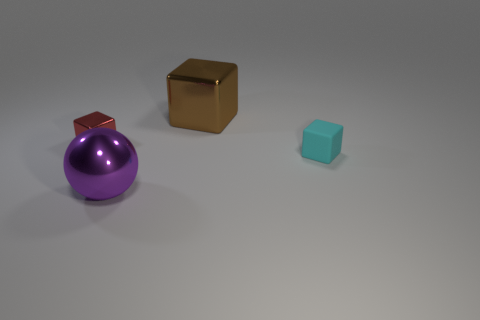Subtract all big cubes. How many cubes are left? 2 Add 3 large blue shiny things. How many objects exist? 7 Subtract all brown blocks. How many blocks are left? 2 Subtract all cubes. How many objects are left? 1 Subtract 2 cubes. How many cubes are left? 1 Subtract all green blocks. How many cyan spheres are left? 0 Subtract all tiny yellow metallic spheres. Subtract all large brown metallic cubes. How many objects are left? 3 Add 1 small shiny cubes. How many small shiny cubes are left? 2 Add 3 large brown rubber cylinders. How many large brown rubber cylinders exist? 3 Subtract 0 purple cubes. How many objects are left? 4 